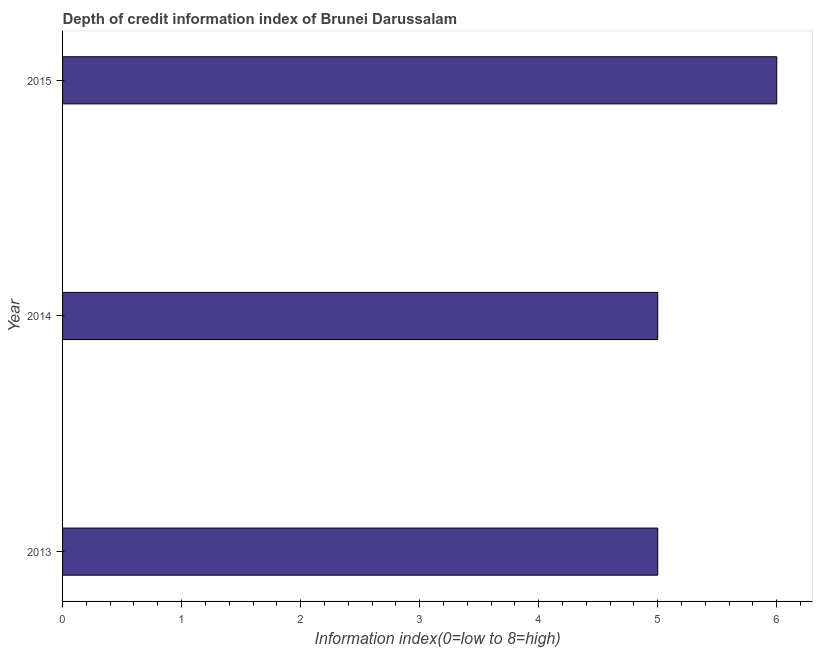Does the graph contain any zero values?
Provide a succinct answer. No. What is the title of the graph?
Keep it short and to the point. Depth of credit information index of Brunei Darussalam. What is the label or title of the X-axis?
Offer a terse response. Information index(0=low to 8=high). What is the label or title of the Y-axis?
Provide a short and direct response. Year. In which year was the depth of credit information index maximum?
Keep it short and to the point. 2015. What is the median depth of credit information index?
Ensure brevity in your answer.  5. In how many years, is the depth of credit information index greater than 3.8 ?
Your answer should be compact. 3. Do a majority of the years between 2015 and 2013 (inclusive) have depth of credit information index greater than 5.4 ?
Give a very brief answer. Yes. Is the depth of credit information index in 2013 less than that in 2014?
Provide a succinct answer. No. Is the difference between the depth of credit information index in 2013 and 2014 greater than the difference between any two years?
Give a very brief answer. No. What is the difference between the highest and the second highest depth of credit information index?
Your response must be concise. 1. In how many years, is the depth of credit information index greater than the average depth of credit information index taken over all years?
Ensure brevity in your answer.  1. How many bars are there?
Ensure brevity in your answer.  3. Are all the bars in the graph horizontal?
Provide a short and direct response. Yes. How many years are there in the graph?
Give a very brief answer. 3. What is the difference between two consecutive major ticks on the X-axis?
Your answer should be compact. 1. What is the Information index(0=low to 8=high) in 2013?
Give a very brief answer. 5. What is the Information index(0=low to 8=high) in 2014?
Ensure brevity in your answer.  5. What is the Information index(0=low to 8=high) of 2015?
Your answer should be compact. 6. What is the difference between the Information index(0=low to 8=high) in 2013 and 2014?
Offer a very short reply. 0. What is the difference between the Information index(0=low to 8=high) in 2014 and 2015?
Your answer should be compact. -1. What is the ratio of the Information index(0=low to 8=high) in 2013 to that in 2015?
Your response must be concise. 0.83. What is the ratio of the Information index(0=low to 8=high) in 2014 to that in 2015?
Ensure brevity in your answer.  0.83. 